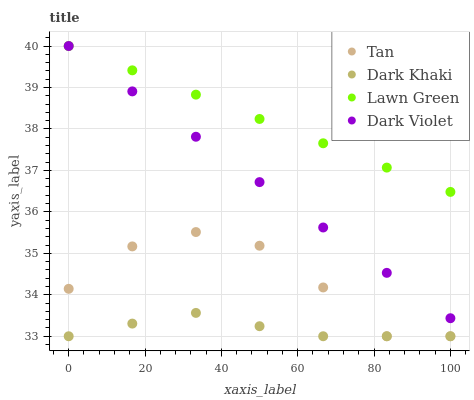Does Dark Khaki have the minimum area under the curve?
Answer yes or no. Yes. Does Lawn Green have the maximum area under the curve?
Answer yes or no. Yes. Does Tan have the minimum area under the curve?
Answer yes or no. No. Does Tan have the maximum area under the curve?
Answer yes or no. No. Is Dark Violet the smoothest?
Answer yes or no. Yes. Is Tan the roughest?
Answer yes or no. Yes. Is Lawn Green the smoothest?
Answer yes or no. No. Is Lawn Green the roughest?
Answer yes or no. No. Does Dark Khaki have the lowest value?
Answer yes or no. Yes. Does Lawn Green have the lowest value?
Answer yes or no. No. Does Dark Violet have the highest value?
Answer yes or no. Yes. Does Tan have the highest value?
Answer yes or no. No. Is Dark Khaki less than Lawn Green?
Answer yes or no. Yes. Is Dark Violet greater than Dark Khaki?
Answer yes or no. Yes. Does Dark Khaki intersect Tan?
Answer yes or no. Yes. Is Dark Khaki less than Tan?
Answer yes or no. No. Is Dark Khaki greater than Tan?
Answer yes or no. No. Does Dark Khaki intersect Lawn Green?
Answer yes or no. No. 